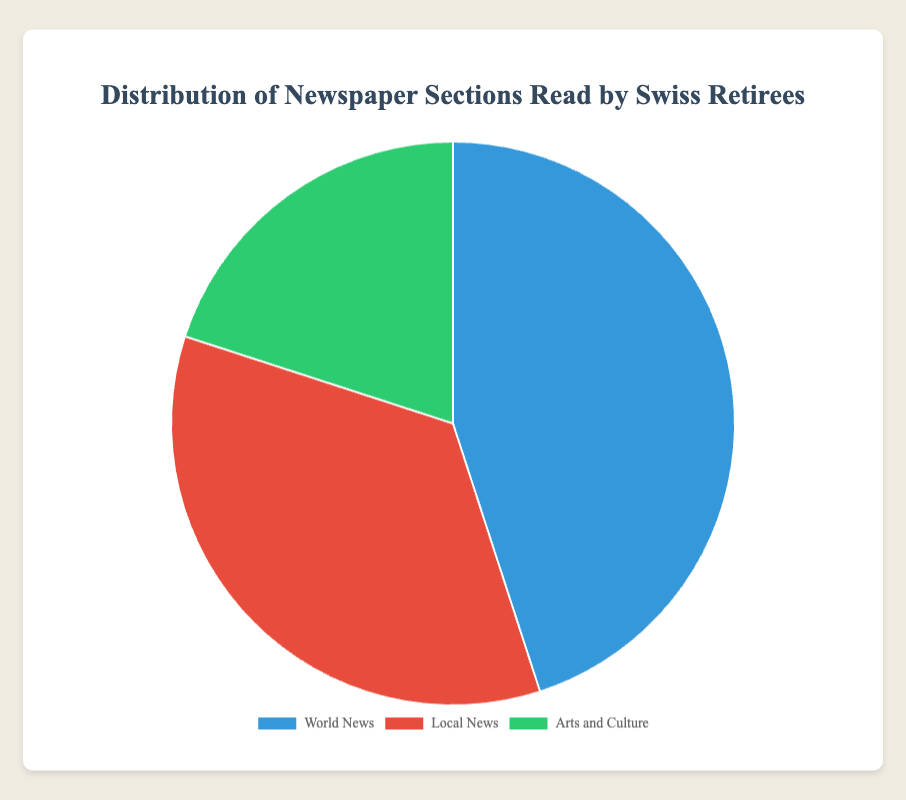What percentage of Swiss retirees read the 'Arts and Culture' section? The figure shows a pie chart with three sections. By looking at the chart, the 'Arts and Culture' slice is labeled with a percentage of 20%.
Answer: 20% Which newspaper section is read by the largest percentage of Swiss retirees? Observing the pie chart, the 'World News' section has the largest slice, indicating it is read by 45% of Swiss retirees.
Answer: World News How much more popular is the 'World News' section compared to the 'Arts and Culture' section? According to the chart, the 'World News' section is read by 45%, while the 'Arts and Culture' section is read by 20%. The difference in popularity is 45% - 20% = 25%.
Answer: 25% What are the combined percentages of retirees who read 'World News' and 'Local News'? From the pie chart, the percentage of retirees who read 'World News' is 45%, and those who read 'Local News' is 35%. Adding these percentages gives 45% + 35% = 80%.
Answer: 80% Which two sections together comprise more than half of the newspaper readings? By examining the pie chart, the 'World News' section accounts for 45% and the 'Local News' section accounts for 35%. Together, they comprise 45% + 35% = 80%, which is more than half.
Answer: World News and Local News Is the percentage of Swiss retirees who read 'Local News' more or less than the percentage who read 'Arts and Culture'? The pie chart shows that 'Local News' is read by 35% of retirees, while 'Arts and Culture' is read by 20%. Therefore, 'Local News' is read by a higher percentage.
Answer: More By how many percentage points does the 'Local News' section exceed the 'Arts and Culture' section? The figure shows that the percentage for 'Local News' is 35% and for 'Arts and Culture' is 20%. The difference is 35% - 20% = 15 percentage points.
Answer: 15 If we want to find the average percentage of the three newspaper sections, what would it be? According to the chart data, the percentages are 45% for 'World News', 35% for 'Local News', and 20% for 'Arts and Culture'. The average is calculated as (45% + 35% + 20%) / 3 = 33.33%.
Answer: 33.33% Which section is represented by the green color in the pie chart? Based on the visual attributes of the pie chart, the green color represents the 'Arts and Culture' section.
Answer: Arts and Culture 